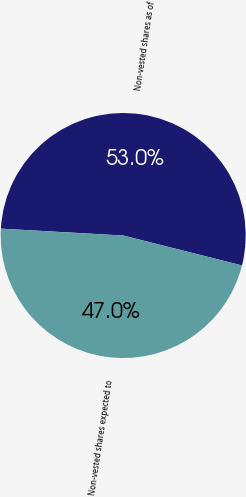Convert chart. <chart><loc_0><loc_0><loc_500><loc_500><pie_chart><fcel>Non-vested shares as of<fcel>Non-vested shares expected to<nl><fcel>53.03%<fcel>46.97%<nl></chart> 